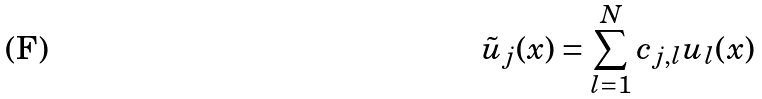Convert formula to latex. <formula><loc_0><loc_0><loc_500><loc_500>\tilde { u } _ { j } ( x ) = \sum _ { l = 1 } ^ { N } c _ { j , l } { u } _ { l } ( x )</formula> 